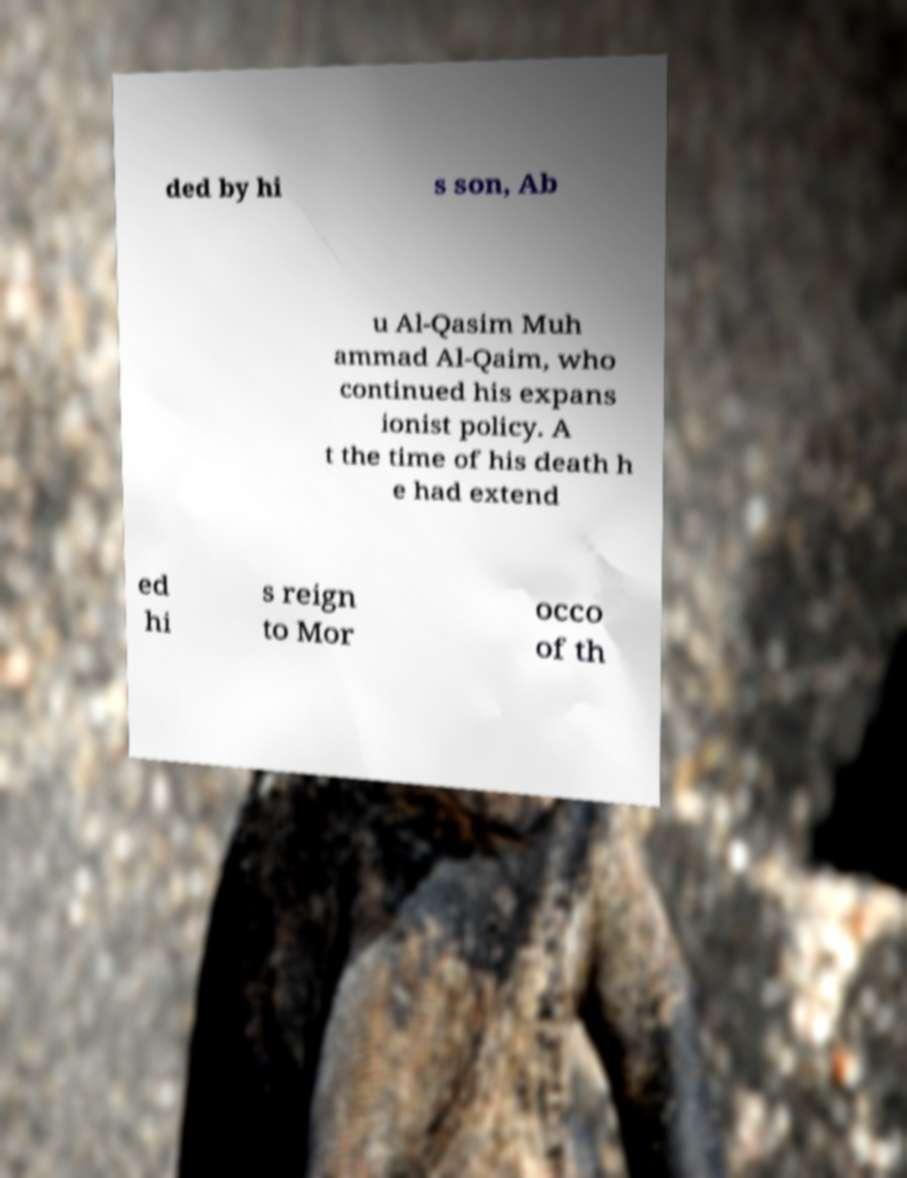For documentation purposes, I need the text within this image transcribed. Could you provide that? ded by hi s son, Ab u Al-Qasim Muh ammad Al-Qaim, who continued his expans ionist policy. A t the time of his death h e had extend ed hi s reign to Mor occo of th 